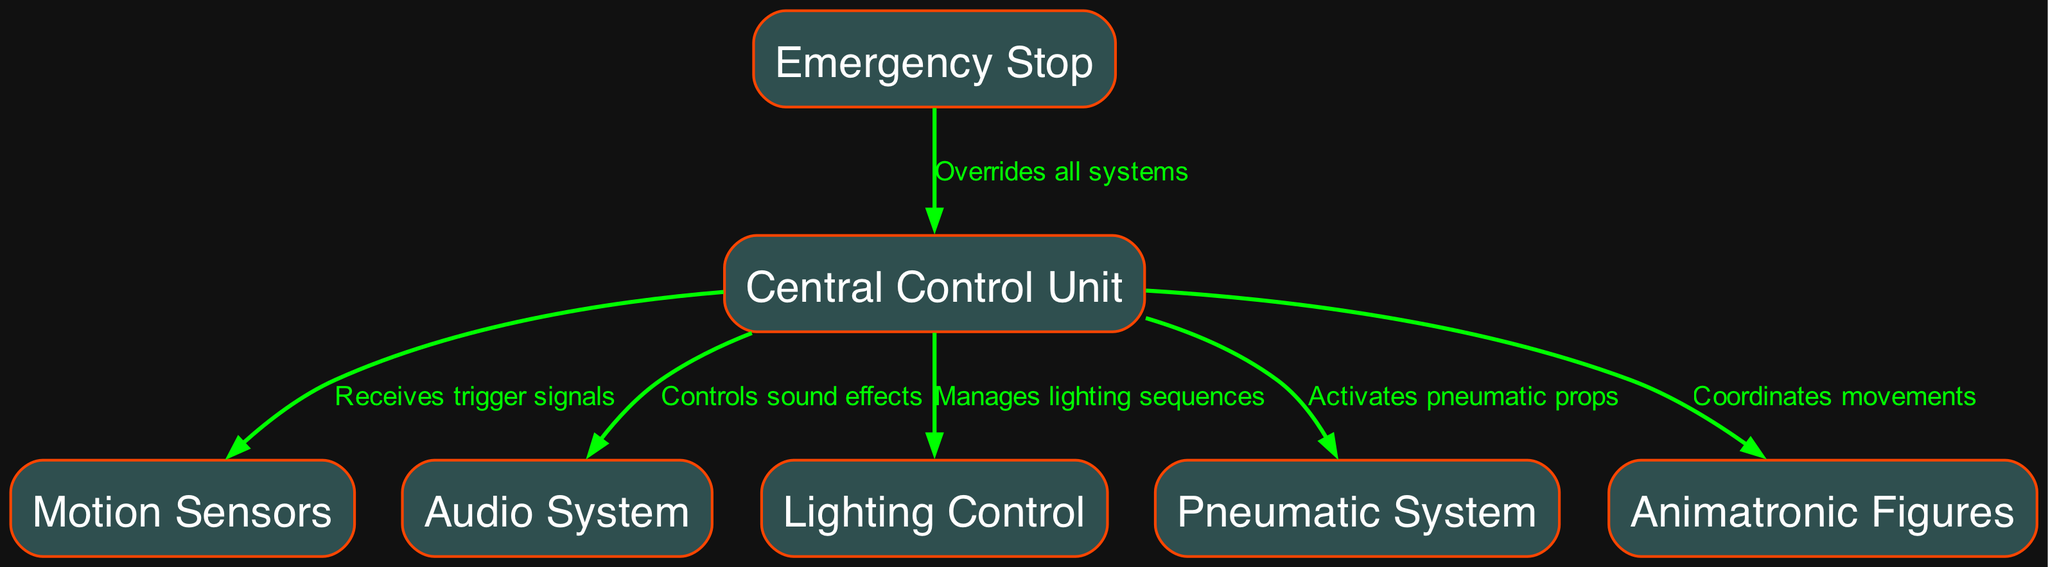What is the total number of nodes in the diagram? The diagram lists the different components of the animatronic control system. By counting each distinct node represented, I identify there are seven nodes labeled from Central Control Unit to Emergency Stop.
Answer: seven What component receives trigger signals? The edge from the Central Control Unit to the Motion Sensors indicates that the Central Control Unit receives trigger signals from the Motion Sensors, which activate the control system.
Answer: Central Control Unit Which component coordinates the movements of the animatronic figures? By looking at the edges, I see that the connection from the Central Control Unit to the Animatronic Figures states that it coordinates their movements, controlling the animatronic action.
Answer: Central Control Unit How many connections does the Central Control Unit have? The Central Control Unit connects to five different components as shown by the edges pointing from it, specifically to the Motion Sensors, Audio System, Lighting Control, Pneumatic System, and Animatronic Figures.
Answer: five Which component overrides all systems? The diagram describes the Emergency Stop component, which has a direct edge pointing to the Central Control Unit, indicating it can override all other systems when activated.
Answer: Emergency Stop What is the function of the Pneumatic System? Following the edges, I can see this component is activated by the Central Control Unit, indicating it plays a role in operating pneumatic props, contributing to the physical action of the animatronics.
Answer: Activates pneumatic props Which node is connected to the Audio System? The edge labeled "Controls sound effects" points directly from the Central Control Unit to the Audio System, demonstrating that this component is responsible for managing sound within the attraction.
Answer: Audio System What two systems does the Central Control Unit manage lighting sequences for? The diagram illustrates that the Central Control Unit manages lighting sequences specifically for the Audio System and Lighting Control, indicating it synchronizes lights with audio and other effects.
Answer: Lighting Control What component is the main hub for the animatronic control system? Based on the connections represented in the diagram, the Central Control Unit serves as the main hub, coordinating all other components such as the sensors, audio, and animatronics.
Answer: Central Control Unit 